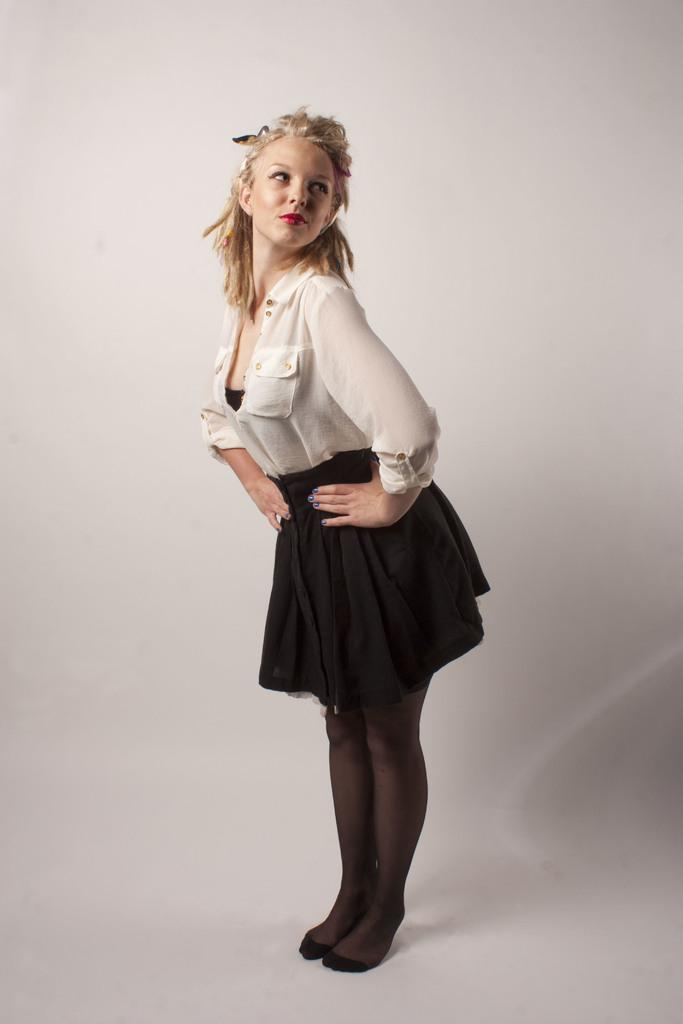Who is the main subject in the image? There is a girl in the image. What is the girl wearing? The girl is wearing a white shirt and a black frock. What color is the wall in the background of the image? The wall in the background of the image is white. Is the girl's partner visible in the image? There is no mention of a partner in the image, so it cannot be determined if one is present. What type of quill is the girl holding in the image? There is no quill present in the image; the girl is not holding any writing instrument. 